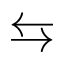<formula> <loc_0><loc_0><loc_500><loc_500>\leftrightarrow s</formula> 